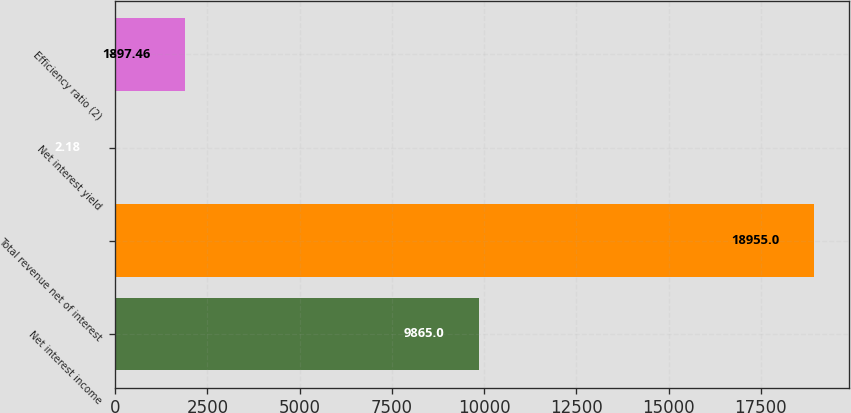Convert chart. <chart><loc_0><loc_0><loc_500><loc_500><bar_chart><fcel>Net interest income<fcel>Total revenue net of interest<fcel>Net interest yield<fcel>Efficiency ratio (2)<nl><fcel>9865<fcel>18955<fcel>2.18<fcel>1897.46<nl></chart> 